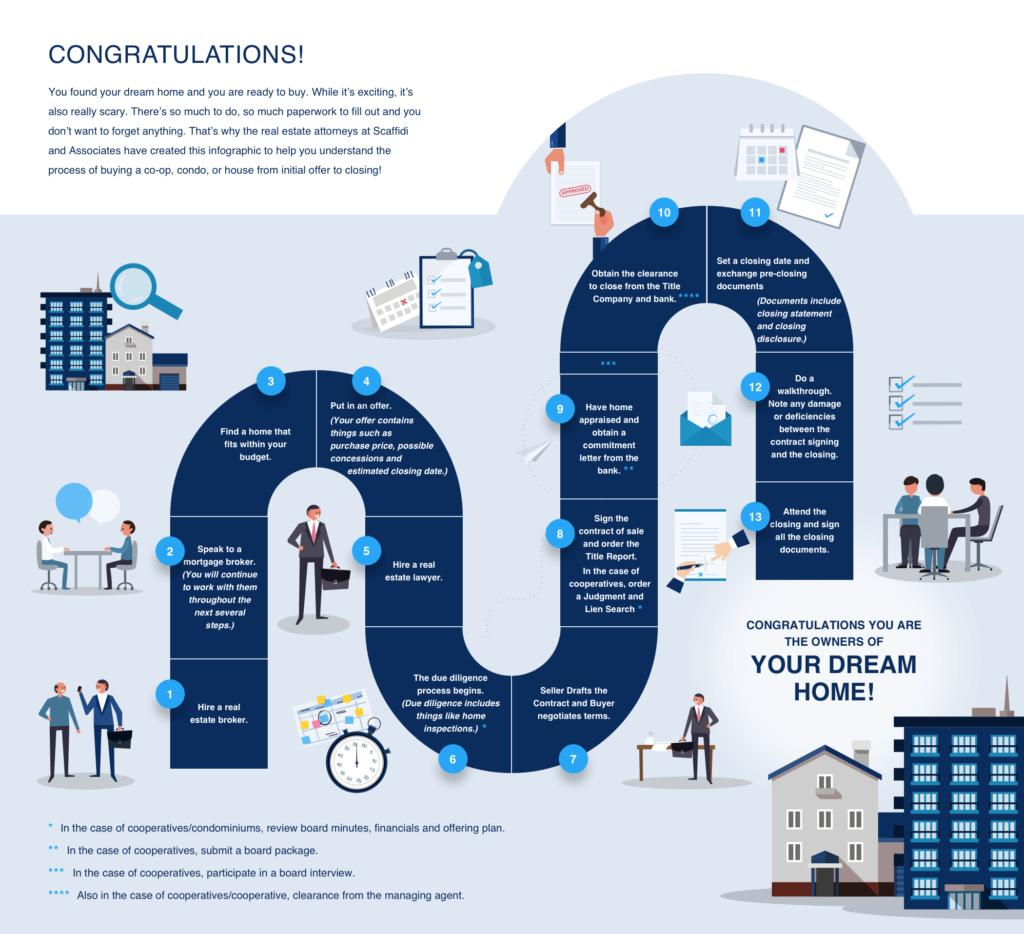Give some essential details in this illustration. The real estate lawyer comes to initially survey the home to be sold in step 6. What is the step that comes before one finally owns a home? The answer is 13. 